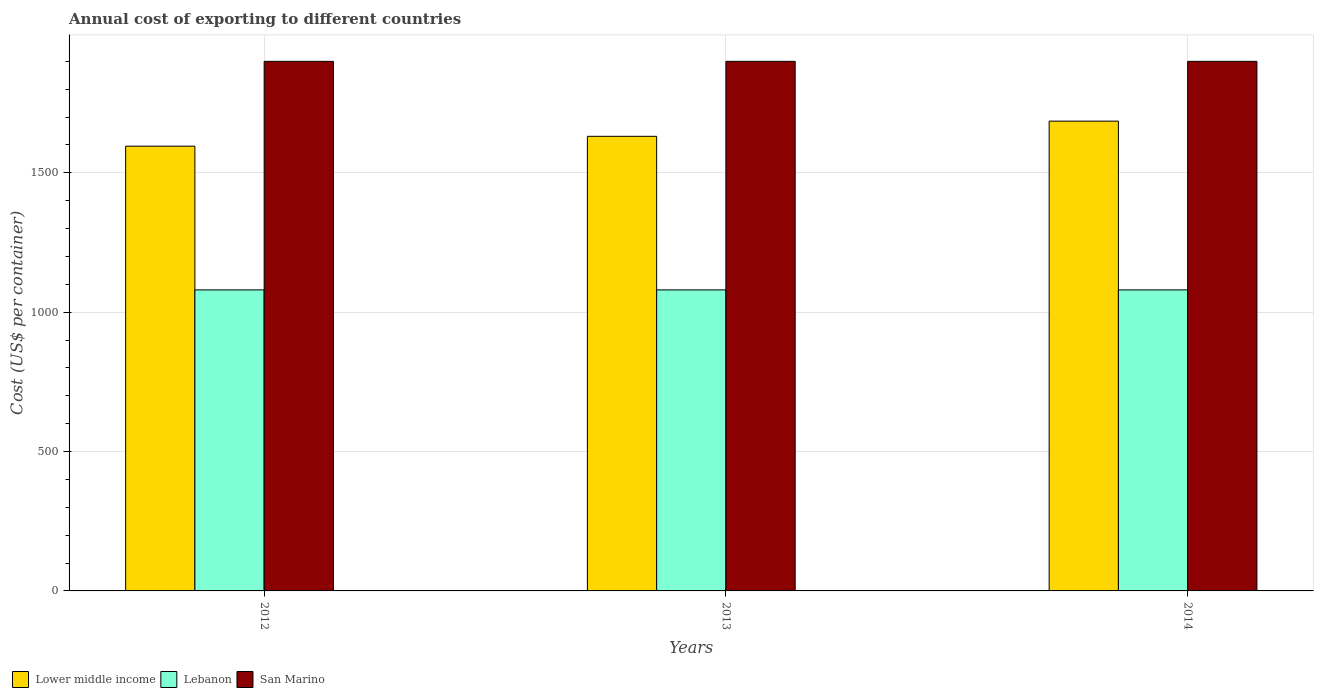How many different coloured bars are there?
Your answer should be very brief. 3. Are the number of bars per tick equal to the number of legend labels?
Make the answer very short. Yes. How many bars are there on the 1st tick from the left?
Keep it short and to the point. 3. How many bars are there on the 2nd tick from the right?
Provide a succinct answer. 3. What is the label of the 1st group of bars from the left?
Your answer should be compact. 2012. What is the total annual cost of exporting in Lebanon in 2013?
Offer a very short reply. 1080. Across all years, what is the maximum total annual cost of exporting in San Marino?
Ensure brevity in your answer.  1900. Across all years, what is the minimum total annual cost of exporting in Lower middle income?
Offer a very short reply. 1595.69. What is the total total annual cost of exporting in Lebanon in the graph?
Your answer should be compact. 3240. What is the difference between the total annual cost of exporting in Lebanon in 2013 and that in 2014?
Your answer should be compact. 0. What is the difference between the total annual cost of exporting in Lower middle income in 2012 and the total annual cost of exporting in Lebanon in 2013?
Your response must be concise. 515.69. What is the average total annual cost of exporting in Lower middle income per year?
Your answer should be compact. 1637.42. In the year 2014, what is the difference between the total annual cost of exporting in San Marino and total annual cost of exporting in Lebanon?
Provide a succinct answer. 820. What is the ratio of the total annual cost of exporting in Lower middle income in 2012 to that in 2013?
Your answer should be compact. 0.98. Is the total annual cost of exporting in San Marino in 2012 less than that in 2013?
Provide a succinct answer. No. Is the difference between the total annual cost of exporting in San Marino in 2012 and 2013 greater than the difference between the total annual cost of exporting in Lebanon in 2012 and 2013?
Keep it short and to the point. No. What is the difference between the highest and the second highest total annual cost of exporting in Lebanon?
Give a very brief answer. 0. In how many years, is the total annual cost of exporting in Lebanon greater than the average total annual cost of exporting in Lebanon taken over all years?
Offer a very short reply. 0. What does the 3rd bar from the left in 2013 represents?
Your answer should be compact. San Marino. What does the 3rd bar from the right in 2012 represents?
Provide a short and direct response. Lower middle income. Are the values on the major ticks of Y-axis written in scientific E-notation?
Ensure brevity in your answer.  No. Does the graph contain any zero values?
Provide a succinct answer. No. How many legend labels are there?
Give a very brief answer. 3. What is the title of the graph?
Your answer should be compact. Annual cost of exporting to different countries. Does "Canada" appear as one of the legend labels in the graph?
Ensure brevity in your answer.  No. What is the label or title of the X-axis?
Offer a very short reply. Years. What is the label or title of the Y-axis?
Keep it short and to the point. Cost (US$ per container). What is the Cost (US$ per container) of Lower middle income in 2012?
Keep it short and to the point. 1595.69. What is the Cost (US$ per container) of Lebanon in 2012?
Your answer should be very brief. 1080. What is the Cost (US$ per container) of San Marino in 2012?
Ensure brevity in your answer.  1900. What is the Cost (US$ per container) in Lower middle income in 2013?
Offer a very short reply. 1631.02. What is the Cost (US$ per container) of Lebanon in 2013?
Make the answer very short. 1080. What is the Cost (US$ per container) of San Marino in 2013?
Give a very brief answer. 1900. What is the Cost (US$ per container) in Lower middle income in 2014?
Provide a succinct answer. 1685.55. What is the Cost (US$ per container) of Lebanon in 2014?
Offer a very short reply. 1080. What is the Cost (US$ per container) of San Marino in 2014?
Provide a succinct answer. 1900. Across all years, what is the maximum Cost (US$ per container) in Lower middle income?
Give a very brief answer. 1685.55. Across all years, what is the maximum Cost (US$ per container) of Lebanon?
Make the answer very short. 1080. Across all years, what is the maximum Cost (US$ per container) of San Marino?
Give a very brief answer. 1900. Across all years, what is the minimum Cost (US$ per container) of Lower middle income?
Your answer should be very brief. 1595.69. Across all years, what is the minimum Cost (US$ per container) of Lebanon?
Make the answer very short. 1080. Across all years, what is the minimum Cost (US$ per container) in San Marino?
Your response must be concise. 1900. What is the total Cost (US$ per container) in Lower middle income in the graph?
Make the answer very short. 4912.25. What is the total Cost (US$ per container) of Lebanon in the graph?
Your response must be concise. 3240. What is the total Cost (US$ per container) in San Marino in the graph?
Your answer should be compact. 5700. What is the difference between the Cost (US$ per container) in Lower middle income in 2012 and that in 2013?
Offer a terse response. -35.34. What is the difference between the Cost (US$ per container) in Lower middle income in 2012 and that in 2014?
Give a very brief answer. -89.86. What is the difference between the Cost (US$ per container) in Lebanon in 2012 and that in 2014?
Offer a terse response. 0. What is the difference between the Cost (US$ per container) in San Marino in 2012 and that in 2014?
Your response must be concise. 0. What is the difference between the Cost (US$ per container) in Lower middle income in 2013 and that in 2014?
Offer a very short reply. -54.52. What is the difference between the Cost (US$ per container) of Lebanon in 2013 and that in 2014?
Your answer should be very brief. 0. What is the difference between the Cost (US$ per container) of San Marino in 2013 and that in 2014?
Offer a terse response. 0. What is the difference between the Cost (US$ per container) of Lower middle income in 2012 and the Cost (US$ per container) of Lebanon in 2013?
Offer a terse response. 515.69. What is the difference between the Cost (US$ per container) of Lower middle income in 2012 and the Cost (US$ per container) of San Marino in 2013?
Ensure brevity in your answer.  -304.31. What is the difference between the Cost (US$ per container) of Lebanon in 2012 and the Cost (US$ per container) of San Marino in 2013?
Keep it short and to the point. -820. What is the difference between the Cost (US$ per container) in Lower middle income in 2012 and the Cost (US$ per container) in Lebanon in 2014?
Offer a terse response. 515.69. What is the difference between the Cost (US$ per container) in Lower middle income in 2012 and the Cost (US$ per container) in San Marino in 2014?
Provide a short and direct response. -304.31. What is the difference between the Cost (US$ per container) in Lebanon in 2012 and the Cost (US$ per container) in San Marino in 2014?
Ensure brevity in your answer.  -820. What is the difference between the Cost (US$ per container) of Lower middle income in 2013 and the Cost (US$ per container) of Lebanon in 2014?
Give a very brief answer. 551.02. What is the difference between the Cost (US$ per container) in Lower middle income in 2013 and the Cost (US$ per container) in San Marino in 2014?
Your answer should be very brief. -268.98. What is the difference between the Cost (US$ per container) of Lebanon in 2013 and the Cost (US$ per container) of San Marino in 2014?
Ensure brevity in your answer.  -820. What is the average Cost (US$ per container) of Lower middle income per year?
Ensure brevity in your answer.  1637.42. What is the average Cost (US$ per container) of Lebanon per year?
Ensure brevity in your answer.  1080. What is the average Cost (US$ per container) of San Marino per year?
Offer a terse response. 1900. In the year 2012, what is the difference between the Cost (US$ per container) in Lower middle income and Cost (US$ per container) in Lebanon?
Keep it short and to the point. 515.69. In the year 2012, what is the difference between the Cost (US$ per container) in Lower middle income and Cost (US$ per container) in San Marino?
Offer a very short reply. -304.31. In the year 2012, what is the difference between the Cost (US$ per container) in Lebanon and Cost (US$ per container) in San Marino?
Offer a very short reply. -820. In the year 2013, what is the difference between the Cost (US$ per container) of Lower middle income and Cost (US$ per container) of Lebanon?
Offer a very short reply. 551.02. In the year 2013, what is the difference between the Cost (US$ per container) of Lower middle income and Cost (US$ per container) of San Marino?
Offer a very short reply. -268.98. In the year 2013, what is the difference between the Cost (US$ per container) in Lebanon and Cost (US$ per container) in San Marino?
Provide a short and direct response. -820. In the year 2014, what is the difference between the Cost (US$ per container) of Lower middle income and Cost (US$ per container) of Lebanon?
Your answer should be compact. 605.55. In the year 2014, what is the difference between the Cost (US$ per container) in Lower middle income and Cost (US$ per container) in San Marino?
Your response must be concise. -214.45. In the year 2014, what is the difference between the Cost (US$ per container) of Lebanon and Cost (US$ per container) of San Marino?
Provide a succinct answer. -820. What is the ratio of the Cost (US$ per container) in Lower middle income in 2012 to that in 2013?
Ensure brevity in your answer.  0.98. What is the ratio of the Cost (US$ per container) in Lebanon in 2012 to that in 2013?
Provide a short and direct response. 1. What is the ratio of the Cost (US$ per container) of Lower middle income in 2012 to that in 2014?
Your answer should be compact. 0.95. What is the ratio of the Cost (US$ per container) of Lower middle income in 2013 to that in 2014?
Your answer should be compact. 0.97. What is the difference between the highest and the second highest Cost (US$ per container) of Lower middle income?
Provide a short and direct response. 54.52. What is the difference between the highest and the second highest Cost (US$ per container) in San Marino?
Your answer should be very brief. 0. What is the difference between the highest and the lowest Cost (US$ per container) of Lower middle income?
Provide a succinct answer. 89.86. What is the difference between the highest and the lowest Cost (US$ per container) of Lebanon?
Your answer should be compact. 0. 